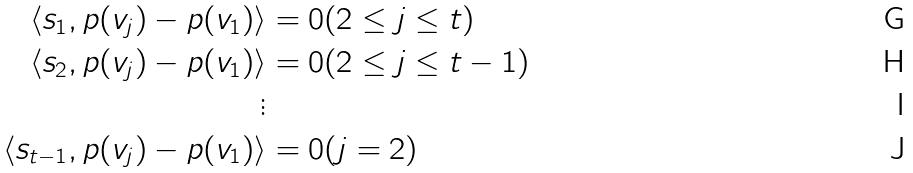<formula> <loc_0><loc_0><loc_500><loc_500>\langle s _ { 1 } , p ( v _ { j } ) - p ( v _ { 1 } ) \rangle & = 0 ( 2 \leq j \leq t ) \\ \langle s _ { 2 } , p ( v _ { j } ) - p ( v _ { 1 } ) \rangle & = 0 ( 2 \leq j \leq t - 1 ) \\ \vdots & \\ \langle s _ { t - 1 } , p ( v _ { j } ) - p ( v _ { 1 } ) \rangle & = 0 ( j = 2 )</formula> 